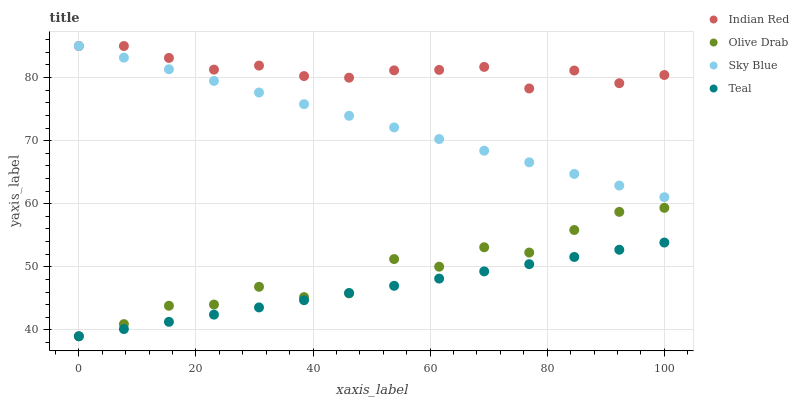Does Teal have the minimum area under the curve?
Answer yes or no. Yes. Does Indian Red have the maximum area under the curve?
Answer yes or no. Yes. Does Sky Blue have the minimum area under the curve?
Answer yes or no. No. Does Sky Blue have the maximum area under the curve?
Answer yes or no. No. Is Sky Blue the smoothest?
Answer yes or no. Yes. Is Olive Drab the roughest?
Answer yes or no. Yes. Is Olive Drab the smoothest?
Answer yes or no. No. Is Sky Blue the roughest?
Answer yes or no. No. Does Teal have the lowest value?
Answer yes or no. Yes. Does Sky Blue have the lowest value?
Answer yes or no. No. Does Indian Red have the highest value?
Answer yes or no. Yes. Does Olive Drab have the highest value?
Answer yes or no. No. Is Teal less than Sky Blue?
Answer yes or no. Yes. Is Indian Red greater than Olive Drab?
Answer yes or no. Yes. Does Indian Red intersect Sky Blue?
Answer yes or no. Yes. Is Indian Red less than Sky Blue?
Answer yes or no. No. Is Indian Red greater than Sky Blue?
Answer yes or no. No. Does Teal intersect Sky Blue?
Answer yes or no. No. 